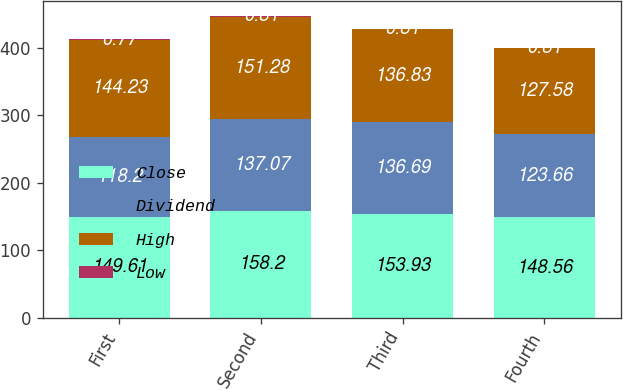Convert chart to OTSL. <chart><loc_0><loc_0><loc_500><loc_500><stacked_bar_chart><ecel><fcel>First<fcel>Second<fcel>Third<fcel>Fourth<nl><fcel>Close<fcel>149.61<fcel>158.2<fcel>153.93<fcel>148.56<nl><fcel>Dividend<fcel>118.2<fcel>137.07<fcel>136.69<fcel>123.66<nl><fcel>High<fcel>144.23<fcel>151.28<fcel>136.83<fcel>127.58<nl><fcel>Low<fcel>0.77<fcel>0.81<fcel>0.81<fcel>0.81<nl></chart> 